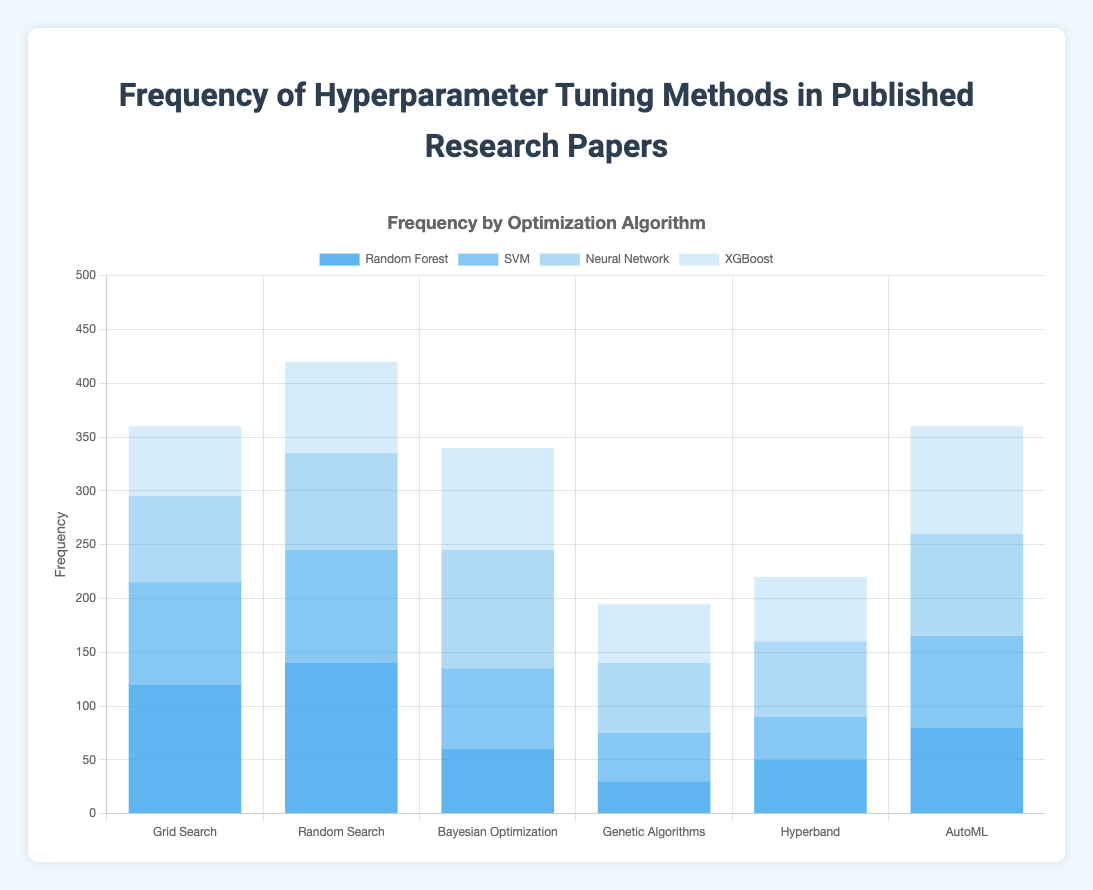Which hyperparameter tuning method has the highest frequency for Random Forest? By looking at the "Random Forest" bars in the figure, we see that "Random Search" has the tallest bar, indicating the highest frequency for Random Forest.
Answer: Random Search Which optimization algorithm for Neural Network has the lowest frequency? Observing the "Neural Network" sections, the bar for "Grid Search" is the shortest among all optimization algorithms.
Answer: Grid Search How many more research papers use Bayesian Optimization for Neural Networks compared to Genetic Algorithms for the same model? The figure shows that Bayesian Optimization has a frequency of 110 for Neural Networks, while Genetic Algorithms have a frequency of 65. The difference is 110 - 65 = 45.
Answer: 45 Are there any optimization algorithms used for SVM that have a frequency lower than 50? Inspecting the bars for SVM, "Hyperband," with a frequency of 40, is the only one below 50.
Answer: Yes What is the average frequency of hyperparameter tuning methods for XGBoost? Summing up the frequencies for XGBoost across all methods: 65 (Grid Search) + 85 (Random Search) + 95 (Bayesian Optimization) + 55 (Genetic Algorithms) + 60 (Hyperband) + 100 (AutoML) = 460. Dividing by the number of methods (6) gives an average of 460 / 6 ≈ 76.67.
Answer: 76.67 Which hyperparameter tuning method is the second most used for SVM? Checking the frequencies for SVM, "Random Search" has the highest at 105, followed by "AutoML" at 85.
Answer: AutoML How much higher is the frequency of AutoML for XGBoost compared to Hyperband for the same model? AutoML for XGBoost has a frequency of 100, while Hyperband has a frequency of 60. The difference is 100 - 60 = 40.
Answer: 40 Which optimization algorithm shows the most balanced use across all models? Evaluating the consistency in bar heights across models, "Random Search" appears to be the most balanced, as it does not have extreme highs or lows.
Answer: Random Search What is the total frequency of Grid Search across all models? Summing the frequencies for Grid Search across all models: 120 (Random Forest) + 95 (SVM) + 80 (Neural Network) + 65 (XGBoost) = 360.
Answer: 360 For which model does Bayesian Optimization have the highest frequency? Observing the "Bayesian Optimization" bars, the highest frequency is for the Neural Network, with a frequency of 110.
Answer: Neural Network 